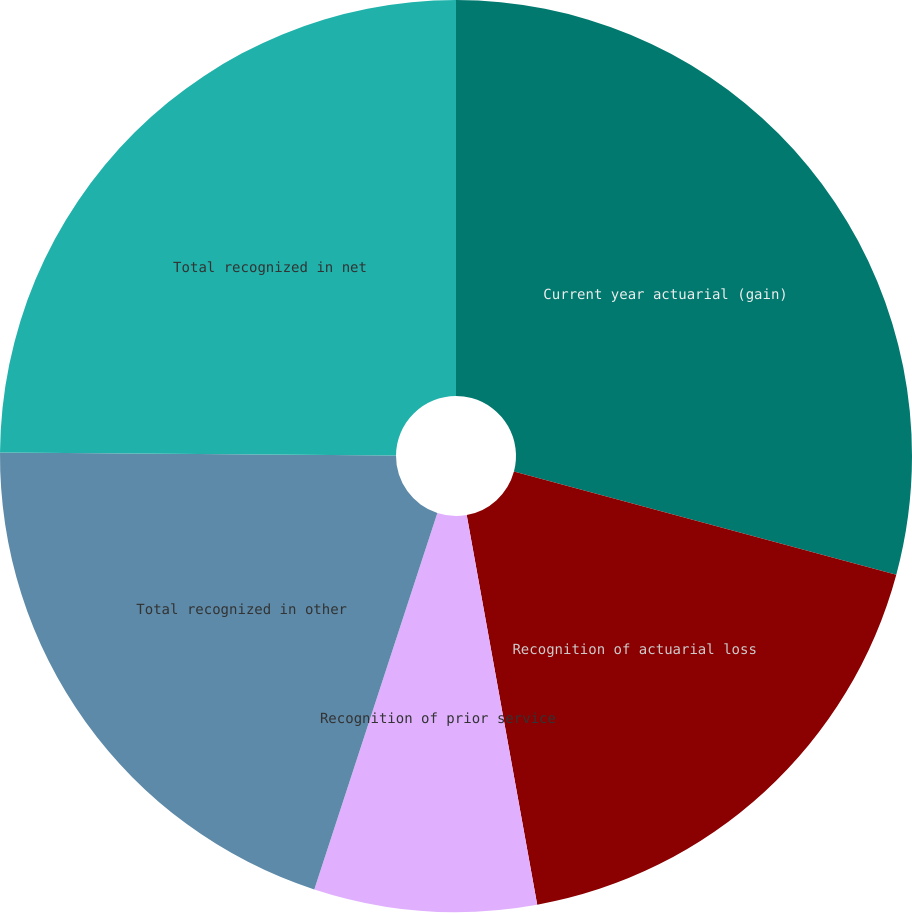Convert chart to OTSL. <chart><loc_0><loc_0><loc_500><loc_500><pie_chart><fcel>Current year actuarial (gain)<fcel>Recognition of actuarial loss<fcel>Recognition of prior service<fcel>Total recognized in other<fcel>Total recognized in net<nl><fcel>29.19%<fcel>17.96%<fcel>7.88%<fcel>20.09%<fcel>24.88%<nl></chart> 